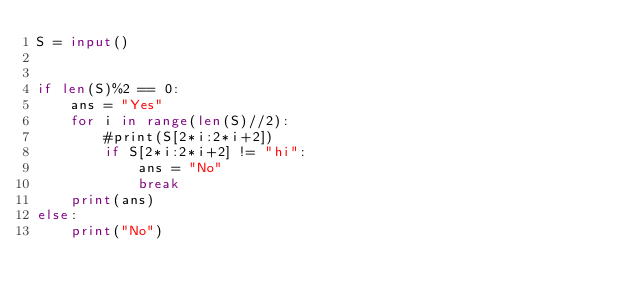<code> <loc_0><loc_0><loc_500><loc_500><_Python_>S = input()


if len(S)%2 == 0:
    ans = "Yes"
    for i in range(len(S)//2):
        #print(S[2*i:2*i+2])
        if S[2*i:2*i+2] != "hi":
            ans = "No"
            break
    print(ans)
else:
    print("No")</code> 